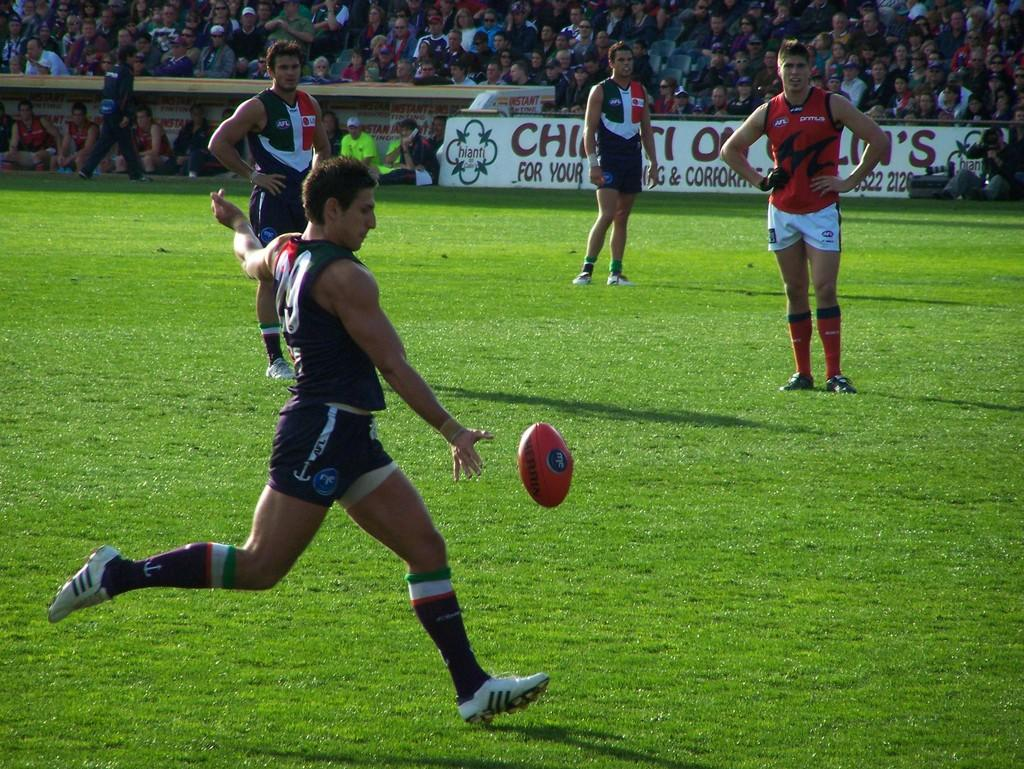What sport are the players engaged in within the image? The players are playing rugby in the image. Where are the players located? The players are on a ground in the image. What type of surface is the ground made of? There is grass on the ground in the image. Can you describe the surroundings of the players? There is an audience visible in the background of the image. What type of throne can be seen in the image? There is no throne present in the image; it features a rugby game being played on a grassy ground with an audience in the background. 